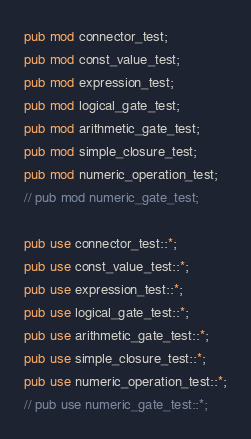<code> <loc_0><loc_0><loc_500><loc_500><_Rust_>pub mod connector_test;
pub mod const_value_test;
pub mod expression_test;
pub mod logical_gate_test;
pub mod arithmetic_gate_test;
pub mod simple_closure_test;
pub mod numeric_operation_test;
// pub mod numeric_gate_test;

pub use connector_test::*;
pub use const_value_test::*;
pub use expression_test::*;
pub use logical_gate_test::*;
pub use arithmetic_gate_test::*;
pub use simple_closure_test::*;
pub use numeric_operation_test::*;
// pub use numeric_gate_test::*;
</code> 